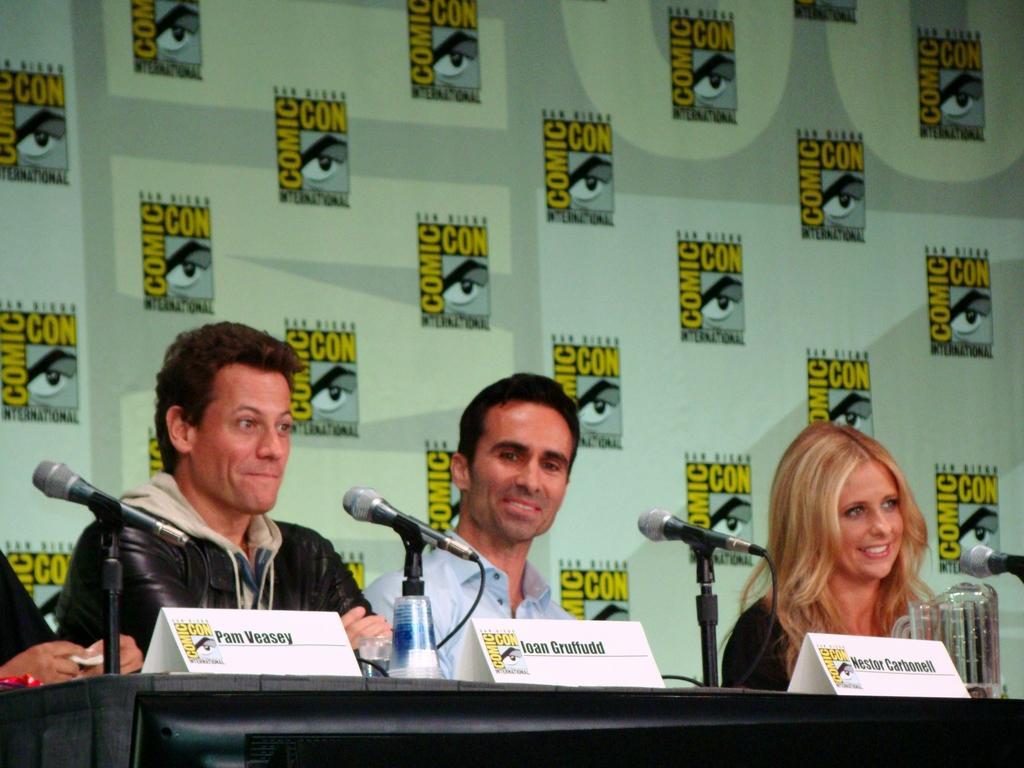Could you give a brief overview of what you see in this image? There are three persons in different color dresses, smiling and sitting in front of a table, on which there are name boards and mics attached to the stands. In the background, there are animated images on a banner. 